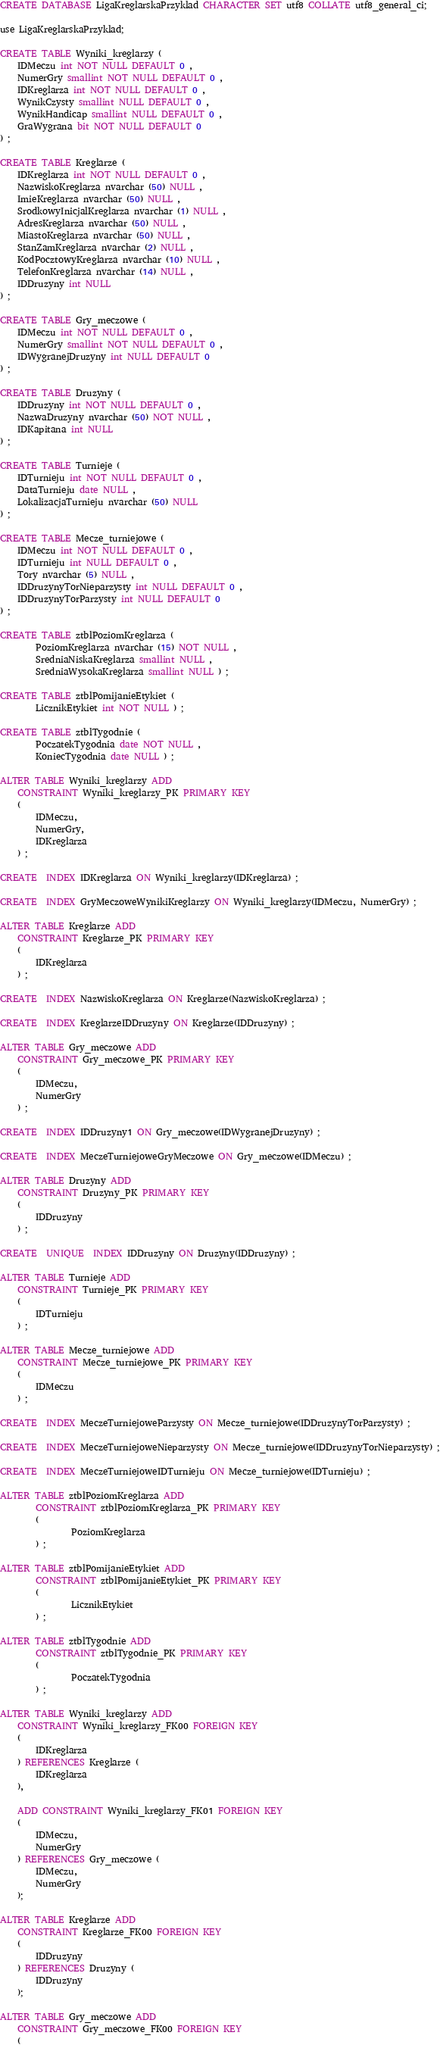Convert code to text. <code><loc_0><loc_0><loc_500><loc_500><_SQL_>CREATE DATABASE LigaKreglarskaPrzyklad CHARACTER SET utf8 COLLATE utf8_general_ci;

use LigaKreglarskaPrzyklad;

CREATE TABLE Wyniki_kreglarzy (
	IDMeczu int NOT NULL DEFAULT 0 ,
	NumerGry smallint NOT NULL DEFAULT 0 ,
	IDKreglarza int NOT NULL DEFAULT 0 ,
	WynikCzysty smallint NULL DEFAULT 0 ,
	WynikHandicap smallint NULL DEFAULT 0 ,
	GraWygrana bit NOT NULL DEFAULT 0 
) ;

CREATE TABLE Kreglarze (
	IDKreglarza int NOT NULL DEFAULT 0 ,
	NazwiskoKreglarza nvarchar (50) NULL ,
	ImieKreglarza nvarchar (50) NULL ,
	SrodkowyInicjalKreglarza nvarchar (1) NULL ,
	AdresKreglarza nvarchar (50) NULL ,
	MiastoKreglarza nvarchar (50) NULL ,
	StanZamKreglarza nvarchar (2) NULL ,
	KodPocztowyKreglarza nvarchar (10) NULL ,
	TelefonKreglarza nvarchar (14) NULL ,
	IDDruzyny int NULL 
) ;

CREATE TABLE Gry_meczowe (
	IDMeczu int NOT NULL DEFAULT 0 ,
	NumerGry smallint NOT NULL DEFAULT 0 ,
	IDWygranejDruzyny int NULL DEFAULT 0 
) ;

CREATE TABLE Druzyny (
	IDDruzyny int NOT NULL DEFAULT 0 ,
	NazwaDruzyny nvarchar (50) NOT NULL ,
	IDKapitana int NULL 
) ;

CREATE TABLE Turnieje (
	IDTurnieju int NOT NULL DEFAULT 0 ,
	DataTurnieju date NULL ,
	LokalizacjaTurnieju nvarchar (50) NULL 
) ;

CREATE TABLE Mecze_turniejowe (
	IDMeczu int NOT NULL DEFAULT 0 ,
	IDTurnieju int NULL DEFAULT 0 ,
	Tory nvarchar (5) NULL ,
	IDDruzynyTorNieparzysty int NULL DEFAULT 0 ,
	IDDruzynyTorParzysty int NULL DEFAULT 0 
) ;

CREATE TABLE ztblPoziomKreglarza (
        PoziomKreglarza nvarchar (15) NOT NULL , 
        SredniaNiskaKreglarza smallint NULL ,
        SredniaWysokaKreglarza smallint NULL ) ;

CREATE TABLE ztblPomijanieEtykiet ( 
        LicznikEtykiet int NOT NULL ) ;

CREATE TABLE ztblTygodnie (
        PoczatekTygodnia date NOT NULL ,
        KoniecTygodnia date NULL ) ;

ALTER TABLE Wyniki_kreglarzy ADD
	CONSTRAINT Wyniki_kreglarzy_PK PRIMARY KEY
	(
		IDMeczu,
		NumerGry,
		IDKreglarza
	) ;

CREATE  INDEX IDKreglarza ON Wyniki_kreglarzy(IDKreglarza) ;

CREATE  INDEX GryMeczoweWynikiKreglarzy ON Wyniki_kreglarzy(IDMeczu, NumerGry) ;

ALTER TABLE Kreglarze ADD
	CONSTRAINT Kreglarze_PK PRIMARY KEY
	(
		IDKreglarza
	) ;

CREATE  INDEX NazwiskoKreglarza ON Kreglarze(NazwiskoKreglarza) ;

CREATE  INDEX KreglarzeIDDruzyny ON Kreglarze(IDDruzyny) ;

ALTER TABLE Gry_meczowe ADD
	CONSTRAINT Gry_meczowe_PK PRIMARY KEY
	(
		IDMeczu,
		NumerGry
	) ;

CREATE  INDEX IDDruzyny1 ON Gry_meczowe(IDWygranejDruzyny) ;

CREATE  INDEX MeczeTurniejoweGryMeczowe ON Gry_meczowe(IDMeczu) ;

ALTER TABLE Druzyny ADD 
	CONSTRAINT Druzyny_PK PRIMARY KEY
	(
		IDDruzyny
	) ;

CREATE  UNIQUE  INDEX IDDruzyny ON Druzyny(IDDruzyny) ;

ALTER TABLE Turnieje ADD
	CONSTRAINT Turnieje_PK PRIMARY KEY
	(
		IDTurnieju
	) ;

ALTER TABLE Mecze_turniejowe ADD
	CONSTRAINT Mecze_turniejowe_PK PRIMARY KEY
	(
		IDMeczu
	) ;

CREATE  INDEX MeczeTurniejoweParzysty ON Mecze_turniejowe(IDDruzynyTorParzysty) ;

CREATE  INDEX MeczeTurniejoweNieparzysty ON Mecze_turniejowe(IDDruzynyTorNieparzysty) ;

CREATE  INDEX MeczeTurniejoweIDTurnieju ON Mecze_turniejowe(IDTurnieju) ;

ALTER TABLE ztblPoziomKreglarza ADD 
        CONSTRAINT ztblPoziomKreglarza_PK PRIMARY KEY 
        ( 
                PoziomKreglarza 
        ) ;

ALTER TABLE ztblPomijanieEtykiet ADD 
        CONSTRAINT ztblPomijanieEtykiet_PK PRIMARY KEY 
        ( 
                LicznikEtykiet 
        ) ;

ALTER TABLE ztblTygodnie ADD
        CONSTRAINT ztblTygodnie_PK PRIMARY KEY 
        ( 
                PoczatekTygodnia 
        ) ;

ALTER TABLE Wyniki_kreglarzy ADD
	CONSTRAINT Wyniki_kreglarzy_FK00 FOREIGN KEY
	(
		IDKreglarza
	) REFERENCES Kreglarze (
		IDKreglarza
	),

	ADD CONSTRAINT Wyniki_kreglarzy_FK01 FOREIGN KEY
	(
		IDMeczu,
		NumerGry
	) REFERENCES Gry_meczowe (
		IDMeczu,
		NumerGry
	);

ALTER TABLE Kreglarze ADD
	CONSTRAINT Kreglarze_FK00 FOREIGN KEY
	(
		IDDruzyny
	) REFERENCES Druzyny (
		IDDruzyny
	);

ALTER TABLE Gry_meczowe ADD
	CONSTRAINT Gry_meczowe_FK00 FOREIGN KEY
	(</code> 